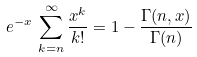Convert formula to latex. <formula><loc_0><loc_0><loc_500><loc_500>e ^ { - x } \, \sum _ { k = n } ^ { \infty } \frac { x ^ { k } } { k ! } = 1 - \frac { \Gamma ( n , x ) } { \Gamma ( n ) }</formula> 